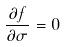Convert formula to latex. <formula><loc_0><loc_0><loc_500><loc_500>\frac { \partial f } { \partial \sigma } = 0</formula> 